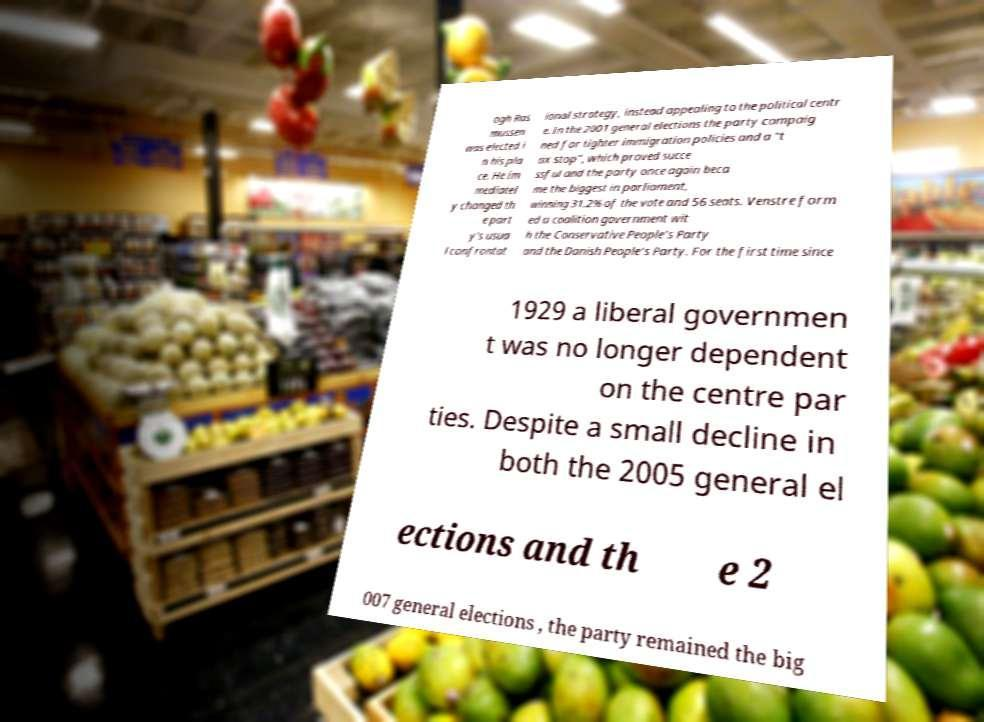Could you assist in decoding the text presented in this image and type it out clearly? ogh Ras mussen was elected i n his pla ce. He im mediatel y changed th e part y's usua l confrontat ional strategy, instead appealing to the political centr e. In the 2001 general elections the party campaig ned for tighter immigration policies and a "t ax stop", which proved succe ssful and the party once again beca me the biggest in parliament, winning 31.2% of the vote and 56 seats. Venstre form ed a coalition government wit h the Conservative People's Party and the Danish People's Party. For the first time since 1929 a liberal governmen t was no longer dependent on the centre par ties. Despite a small decline in both the 2005 general el ections and th e 2 007 general elections , the party remained the big 